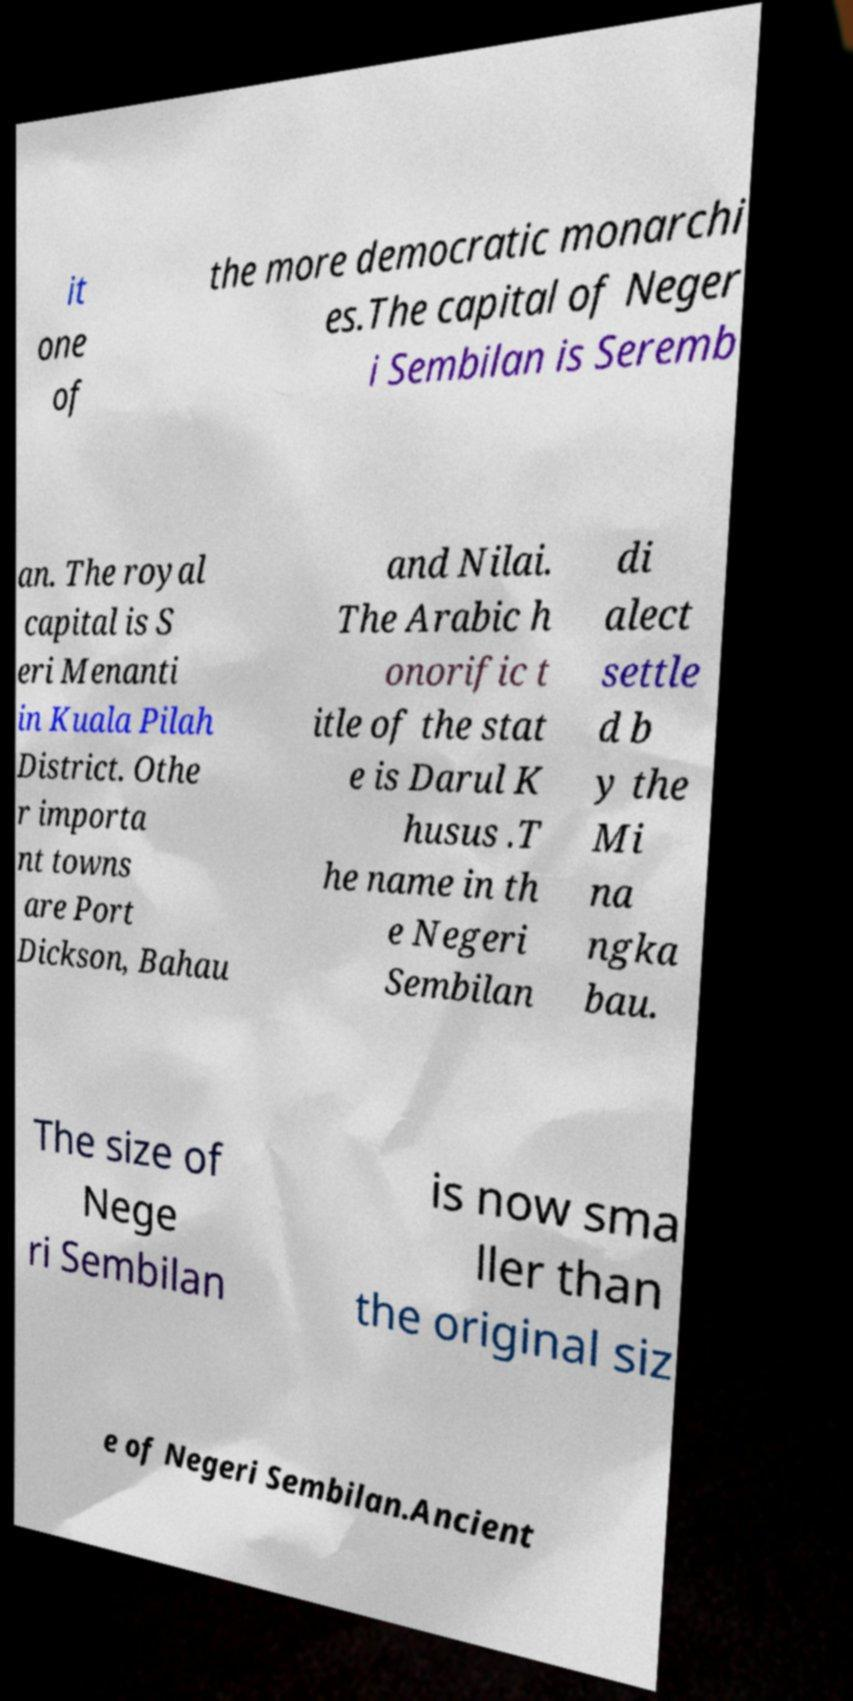What messages or text are displayed in this image? I need them in a readable, typed format. it one of the more democratic monarchi es.The capital of Neger i Sembilan is Seremb an. The royal capital is S eri Menanti in Kuala Pilah District. Othe r importa nt towns are Port Dickson, Bahau and Nilai. The Arabic h onorific t itle of the stat e is Darul K husus .T he name in th e Negeri Sembilan di alect settle d b y the Mi na ngka bau. The size of Nege ri Sembilan is now sma ller than the original siz e of Negeri Sembilan.Ancient 